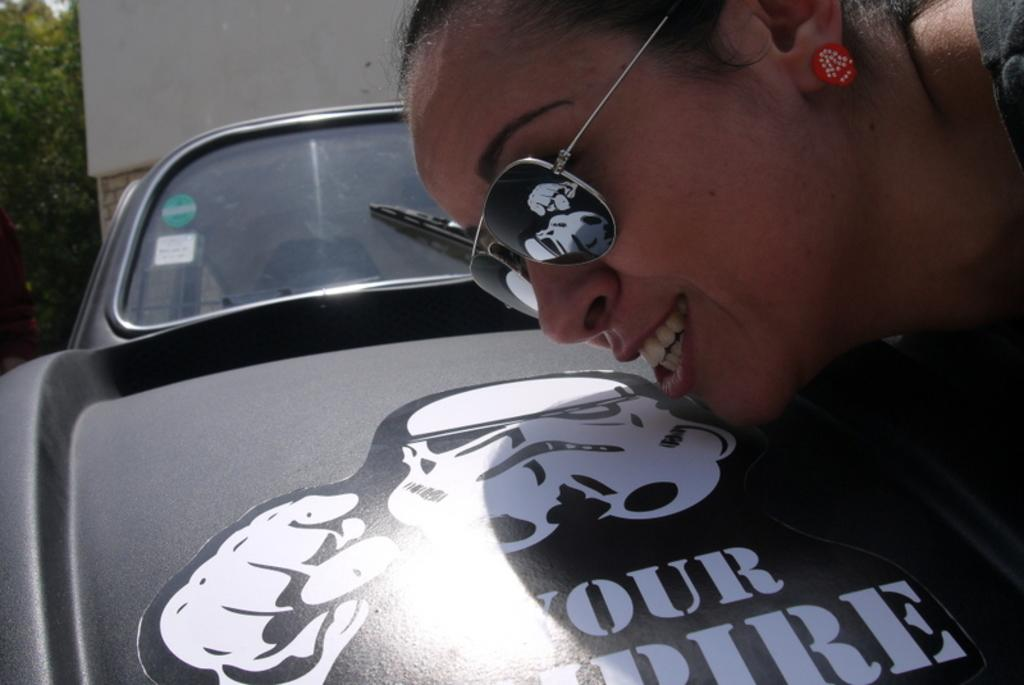What is the main subject in the middle of the image? There is a car in the middle of the image. What is unique about the car's appearance? The car has a tattoo on it. Who is present on the right side of the image? There is a woman on the right side of the image. What is the woman wearing on her face? The woman is wearing goggles. What type of vegetation can be seen on the left side of the image? There are trees on the left side of the image. What type of vase can be seen on the car's hood in the image? There is no vase present on the car's hood in the image. What type of beam is holding up the trees on the left side of the image? There is no beam visible in the image; only trees are present on the left side. 